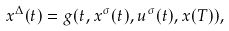Convert formula to latex. <formula><loc_0><loc_0><loc_500><loc_500>x ^ { \Delta } ( t ) = g ( t , x ^ { \sigma } ( t ) , u ^ { \sigma } ( t ) , x ( T ) ) ,</formula> 